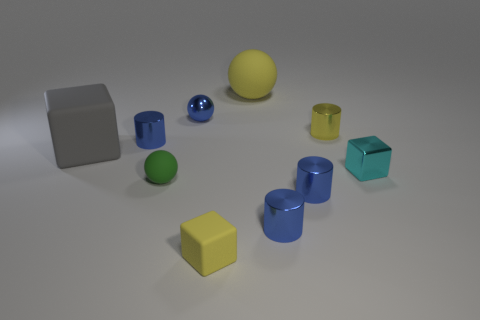There is a small sphere in front of the cyan block; what is its color?
Give a very brief answer. Green. There is a tiny ball that is behind the tiny cyan metallic block; are there any small blue things on the left side of it?
Give a very brief answer. Yes. What number of other things are there of the same color as the small rubber cube?
Provide a succinct answer. 2. Does the block that is to the right of the big yellow thing have the same size as the cylinder that is on the left side of the small matte ball?
Your answer should be very brief. Yes. What size is the yellow rubber thing that is right of the rubber thing in front of the green object?
Your answer should be compact. Large. There is a sphere that is both in front of the big yellow matte sphere and behind the green ball; what material is it?
Your answer should be very brief. Metal. What color is the big rubber cube?
Provide a short and direct response. Gray. What is the shape of the yellow thing in front of the cyan thing?
Provide a succinct answer. Cube. Are there any tiny metallic cylinders that are to the right of the large thing that is on the right side of the blue metal cylinder that is behind the big gray rubber thing?
Make the answer very short. Yes. Are there any large brown metallic spheres?
Provide a succinct answer. No. 